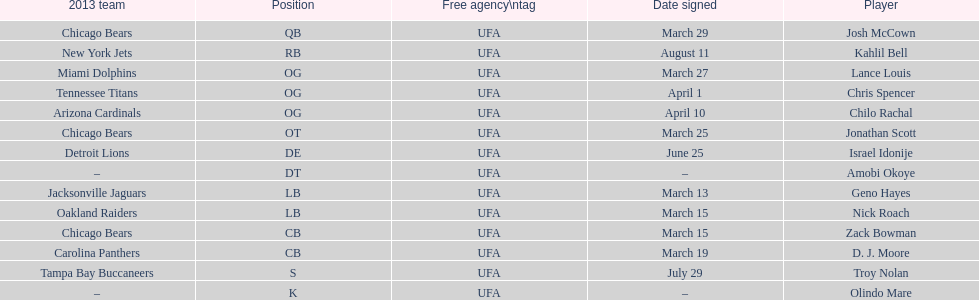Family name is also a first name commencing with "n" Troy Nolan. 